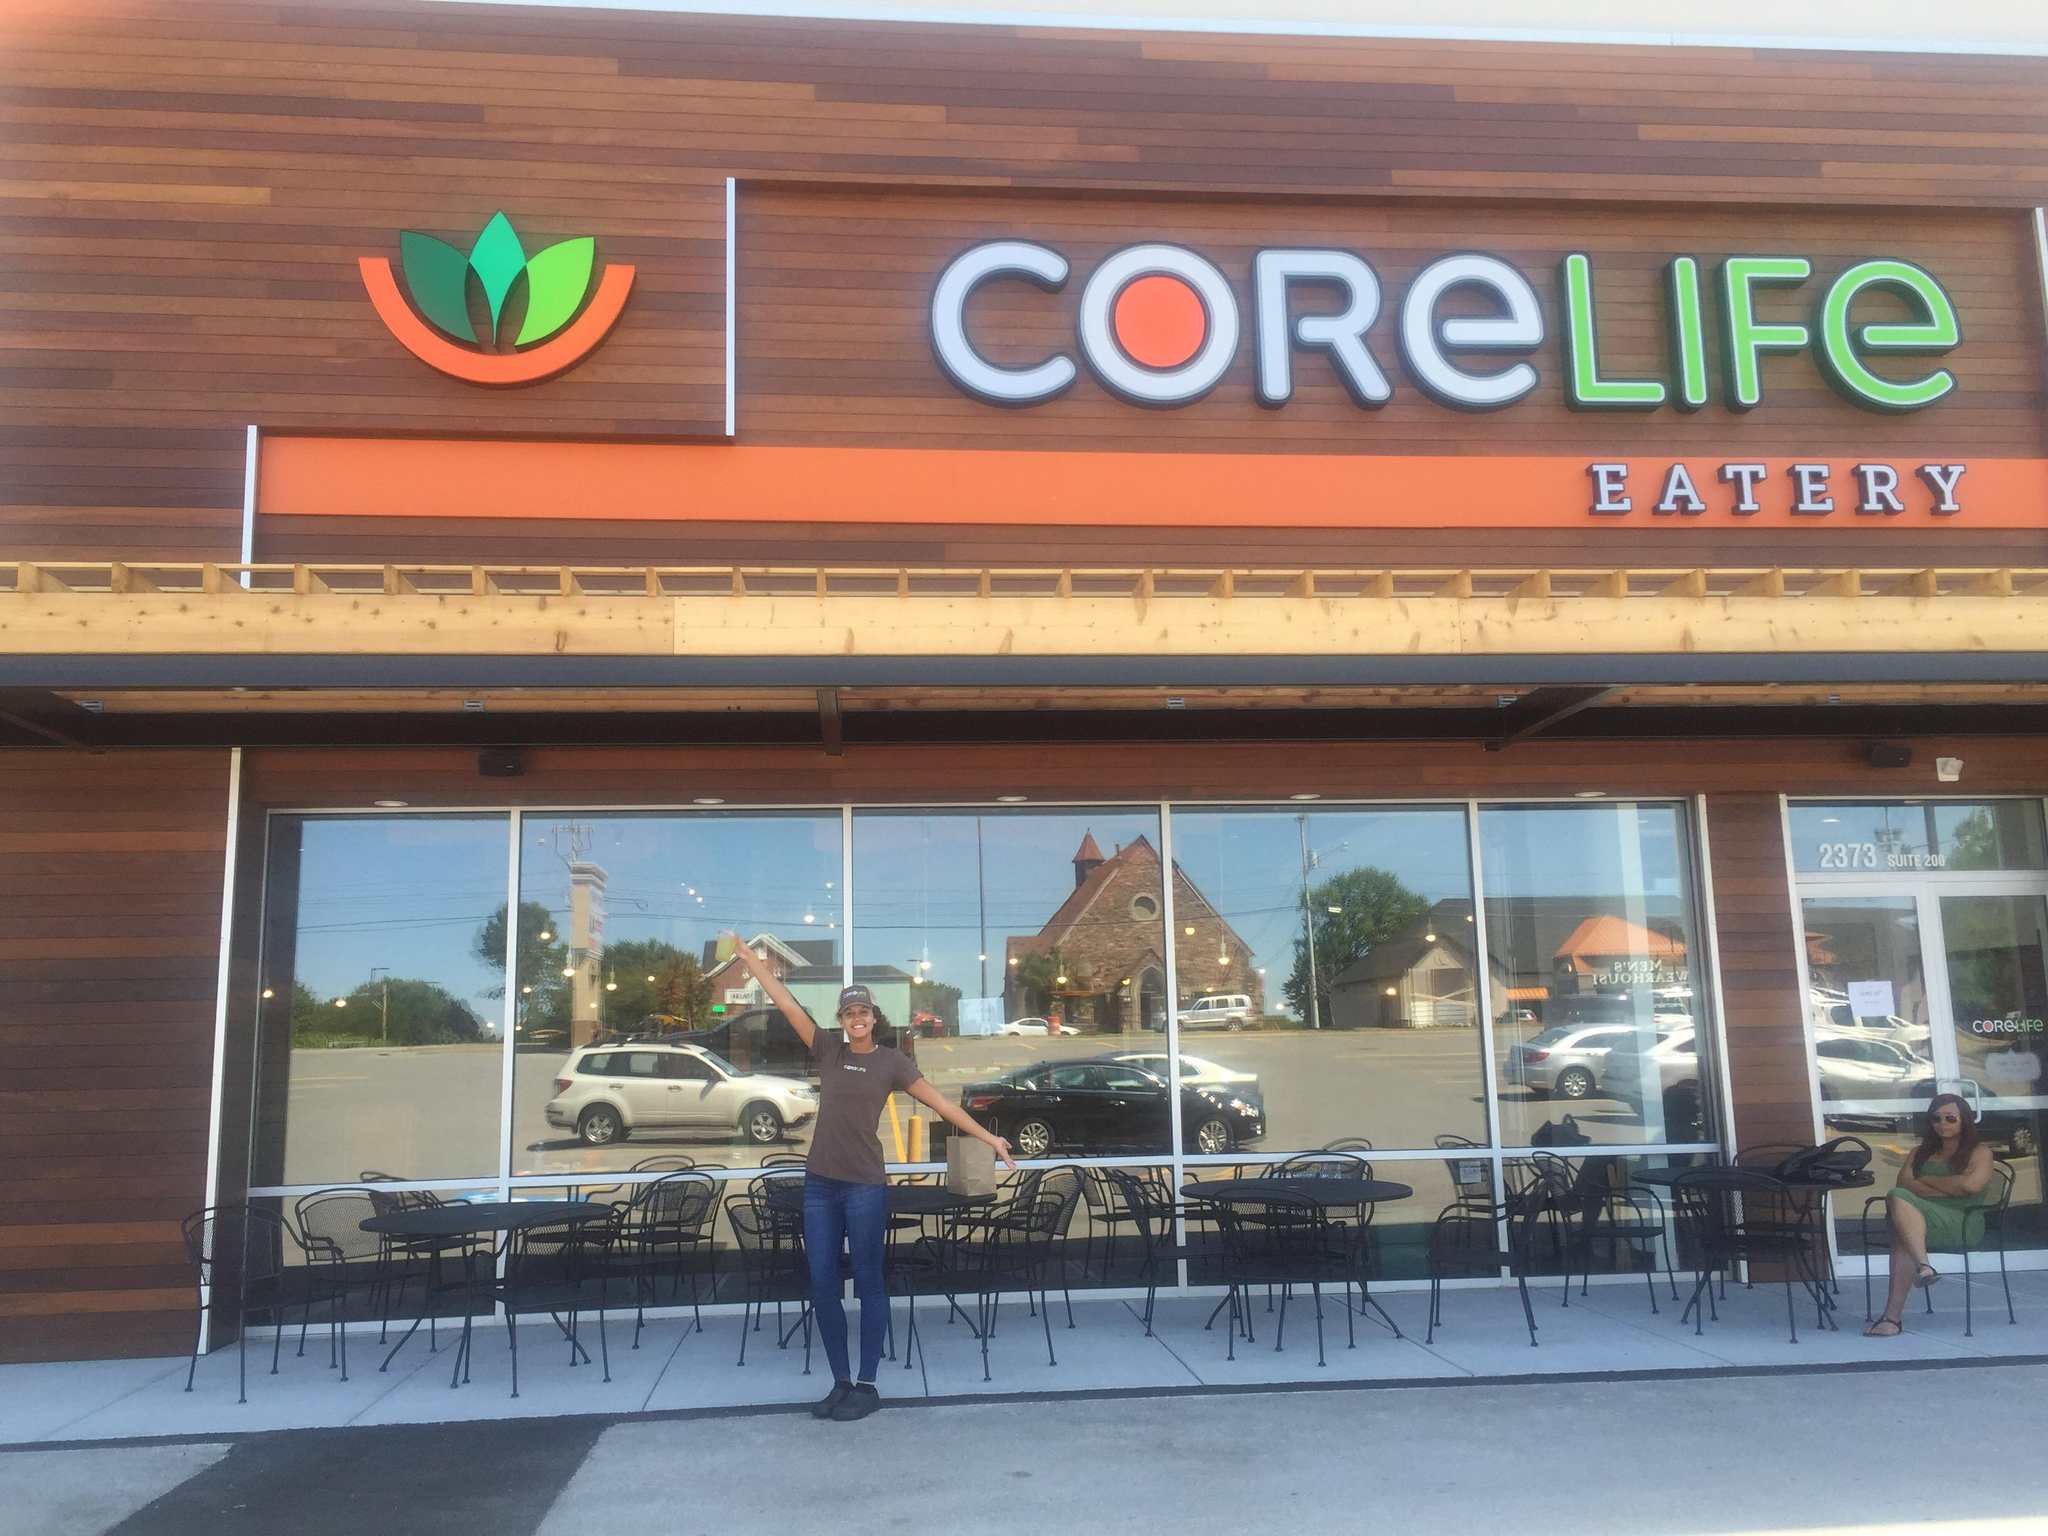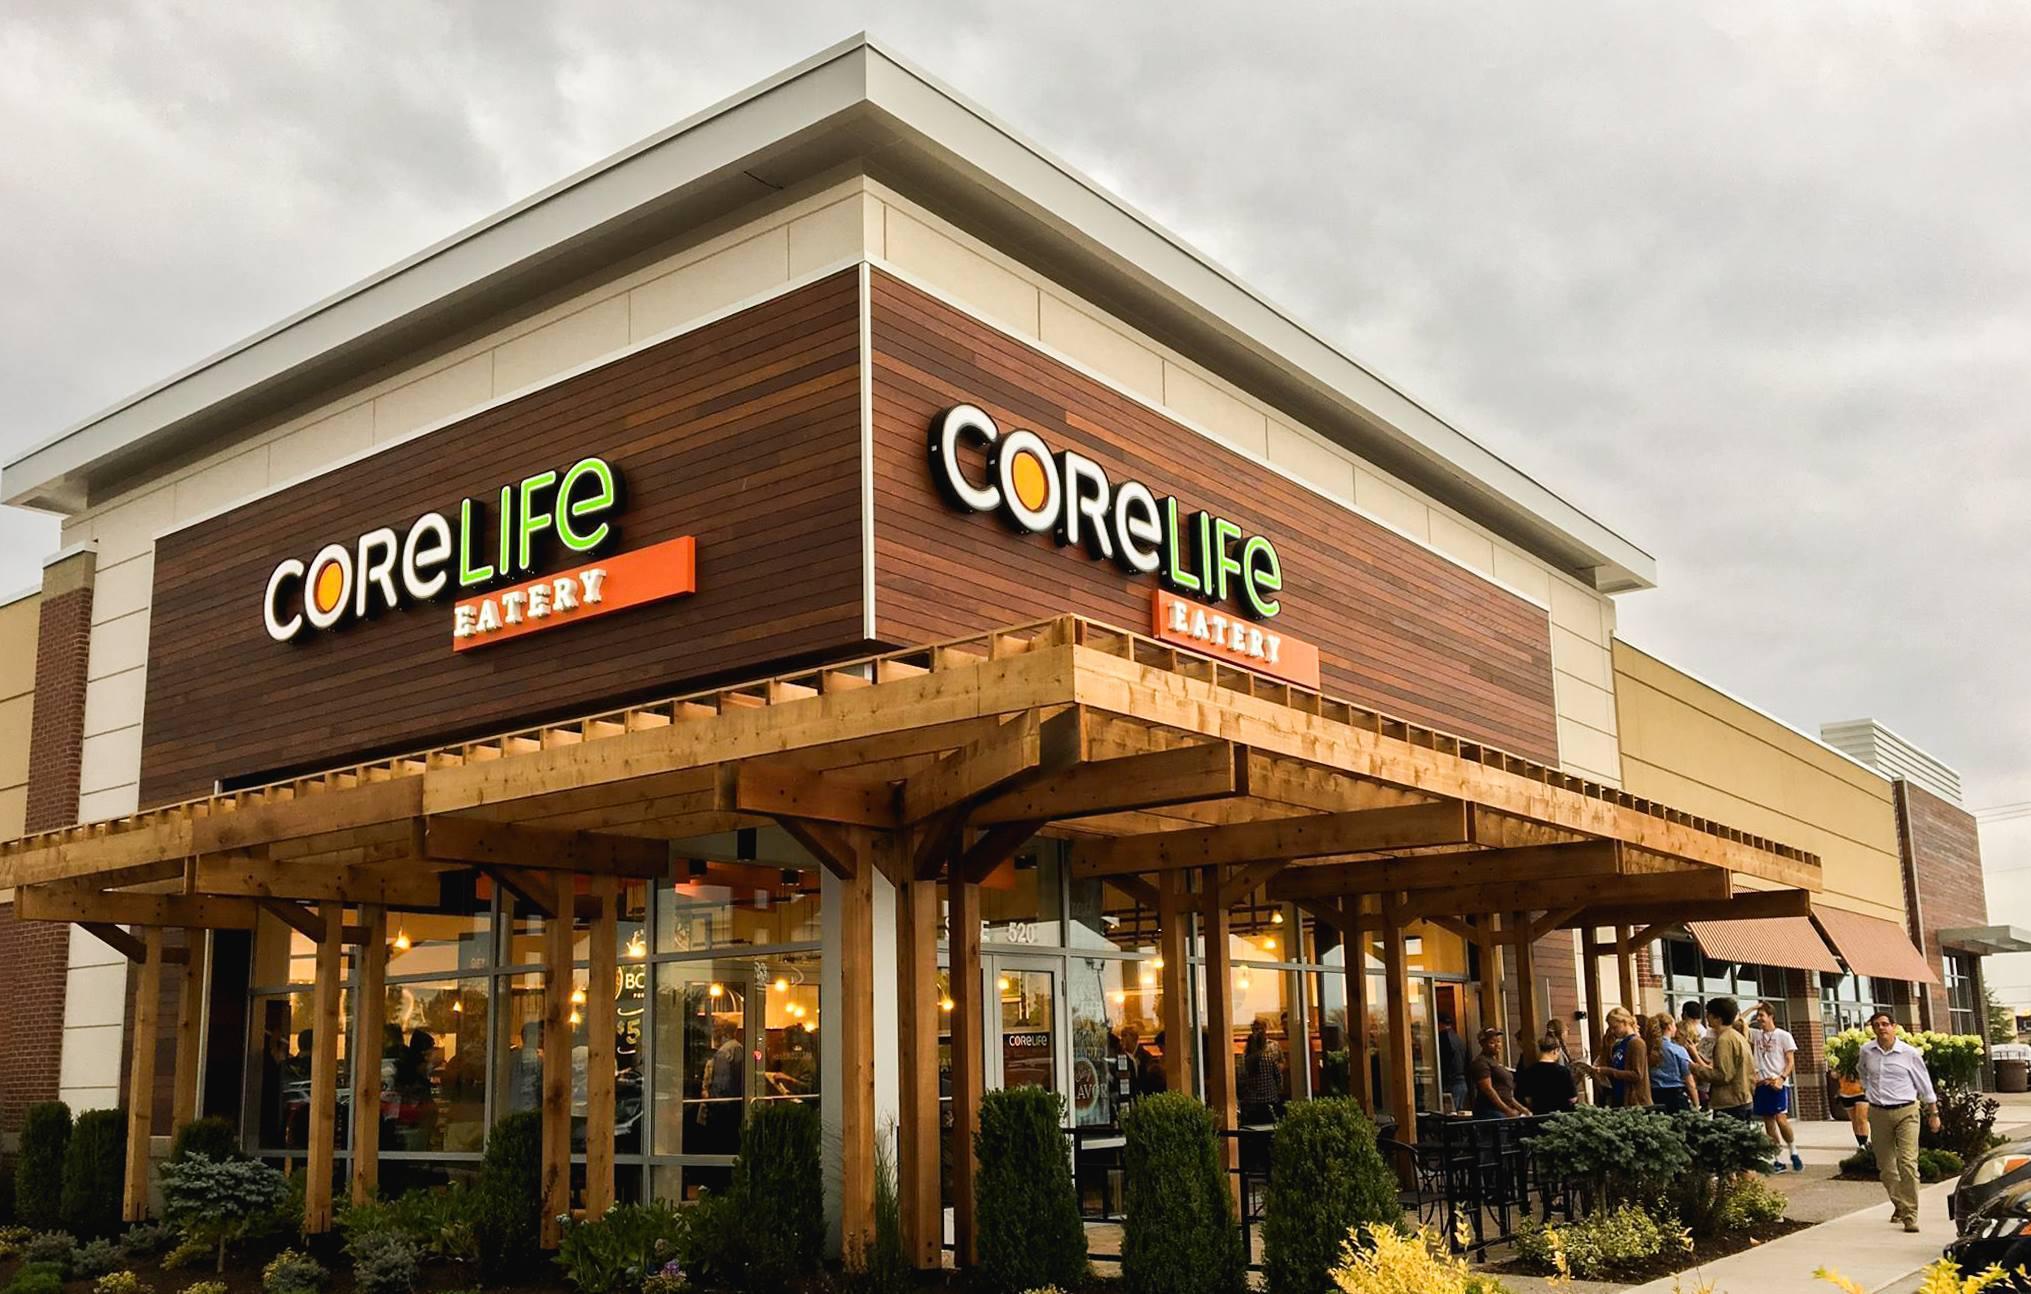The first image is the image on the left, the second image is the image on the right. Given the left and right images, does the statement "Two restaurants are displaying a permanent sign with the name Core Life Eatery." hold true? Answer yes or no. Yes. 